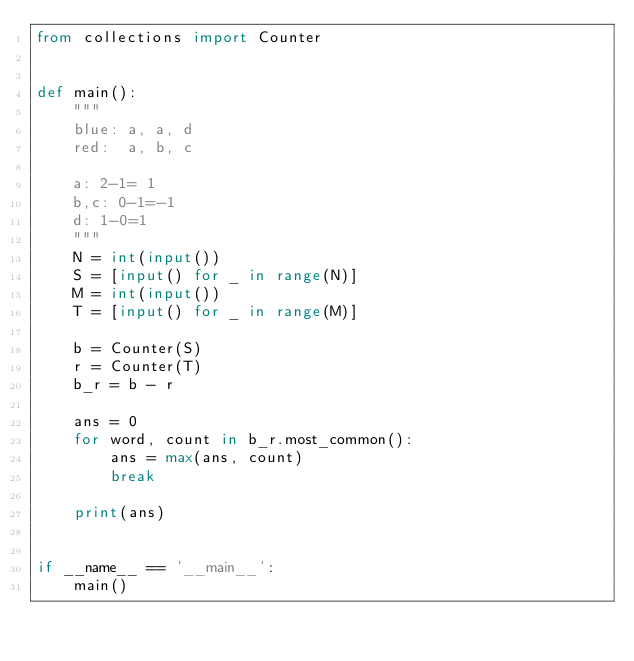Convert code to text. <code><loc_0><loc_0><loc_500><loc_500><_Python_>from collections import Counter


def main():
    """
    blue: a, a, d
    red:  a, b, c

    a: 2-1= 1
    b,c: 0-1=-1
    d: 1-0=1
    """
    N = int(input())
    S = [input() for _ in range(N)]
    M = int(input())
    T = [input() for _ in range(M)]

    b = Counter(S)
    r = Counter(T)
    b_r = b - r

    ans = 0
    for word, count in b_r.most_common():
        ans = max(ans, count)
        break

    print(ans)


if __name__ == '__main__':
    main()
</code> 